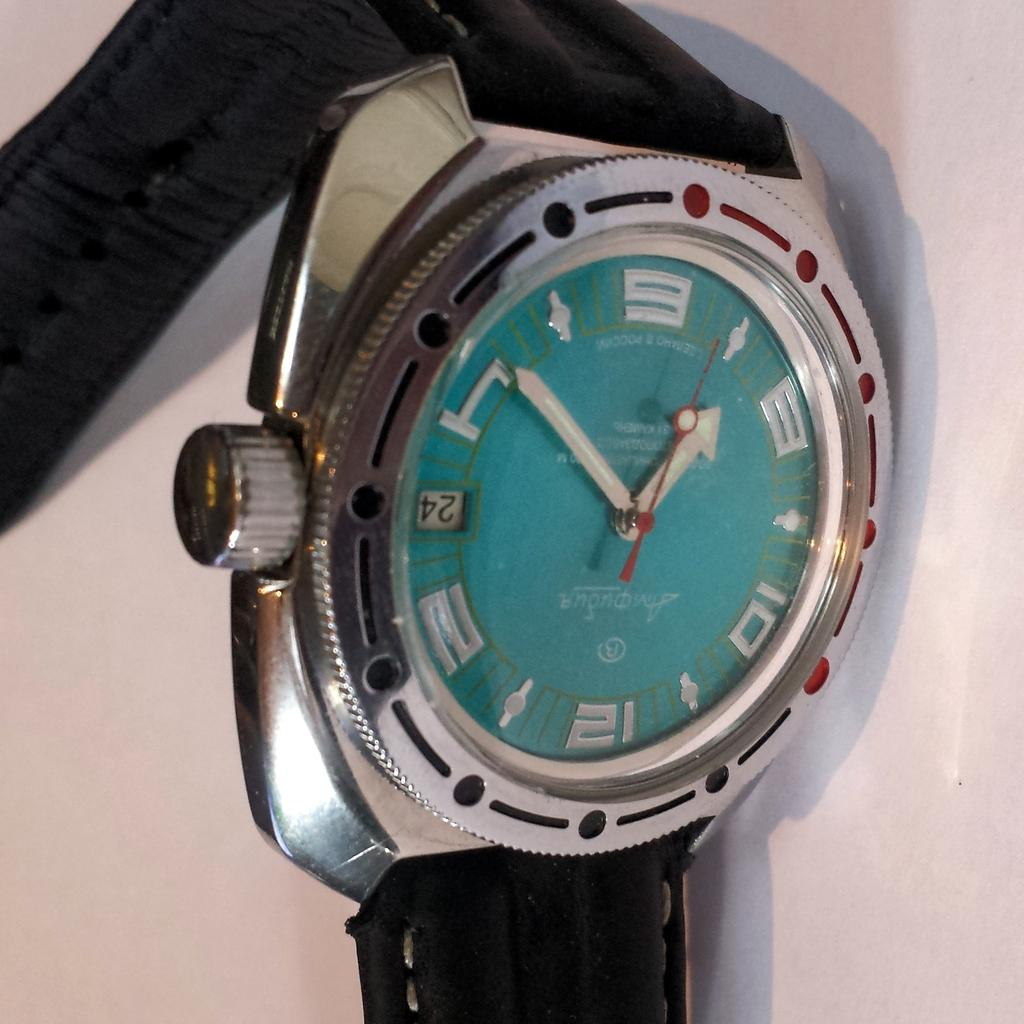What object is located in the front of the image? There is a watch in the front of the image. Can you describe the watch in more detail? Unfortunately, the provided facts do not offer any additional details about the watch. What might the purpose of the watch be in the image? The purpose of the watch in the image is not explicitly stated, but it could be serving as a timekeeping device or simply as a decorative element. What type of grape is being used to clean the watch in the image? There is no grape present in the image, and therefore no such activity can be observed. 